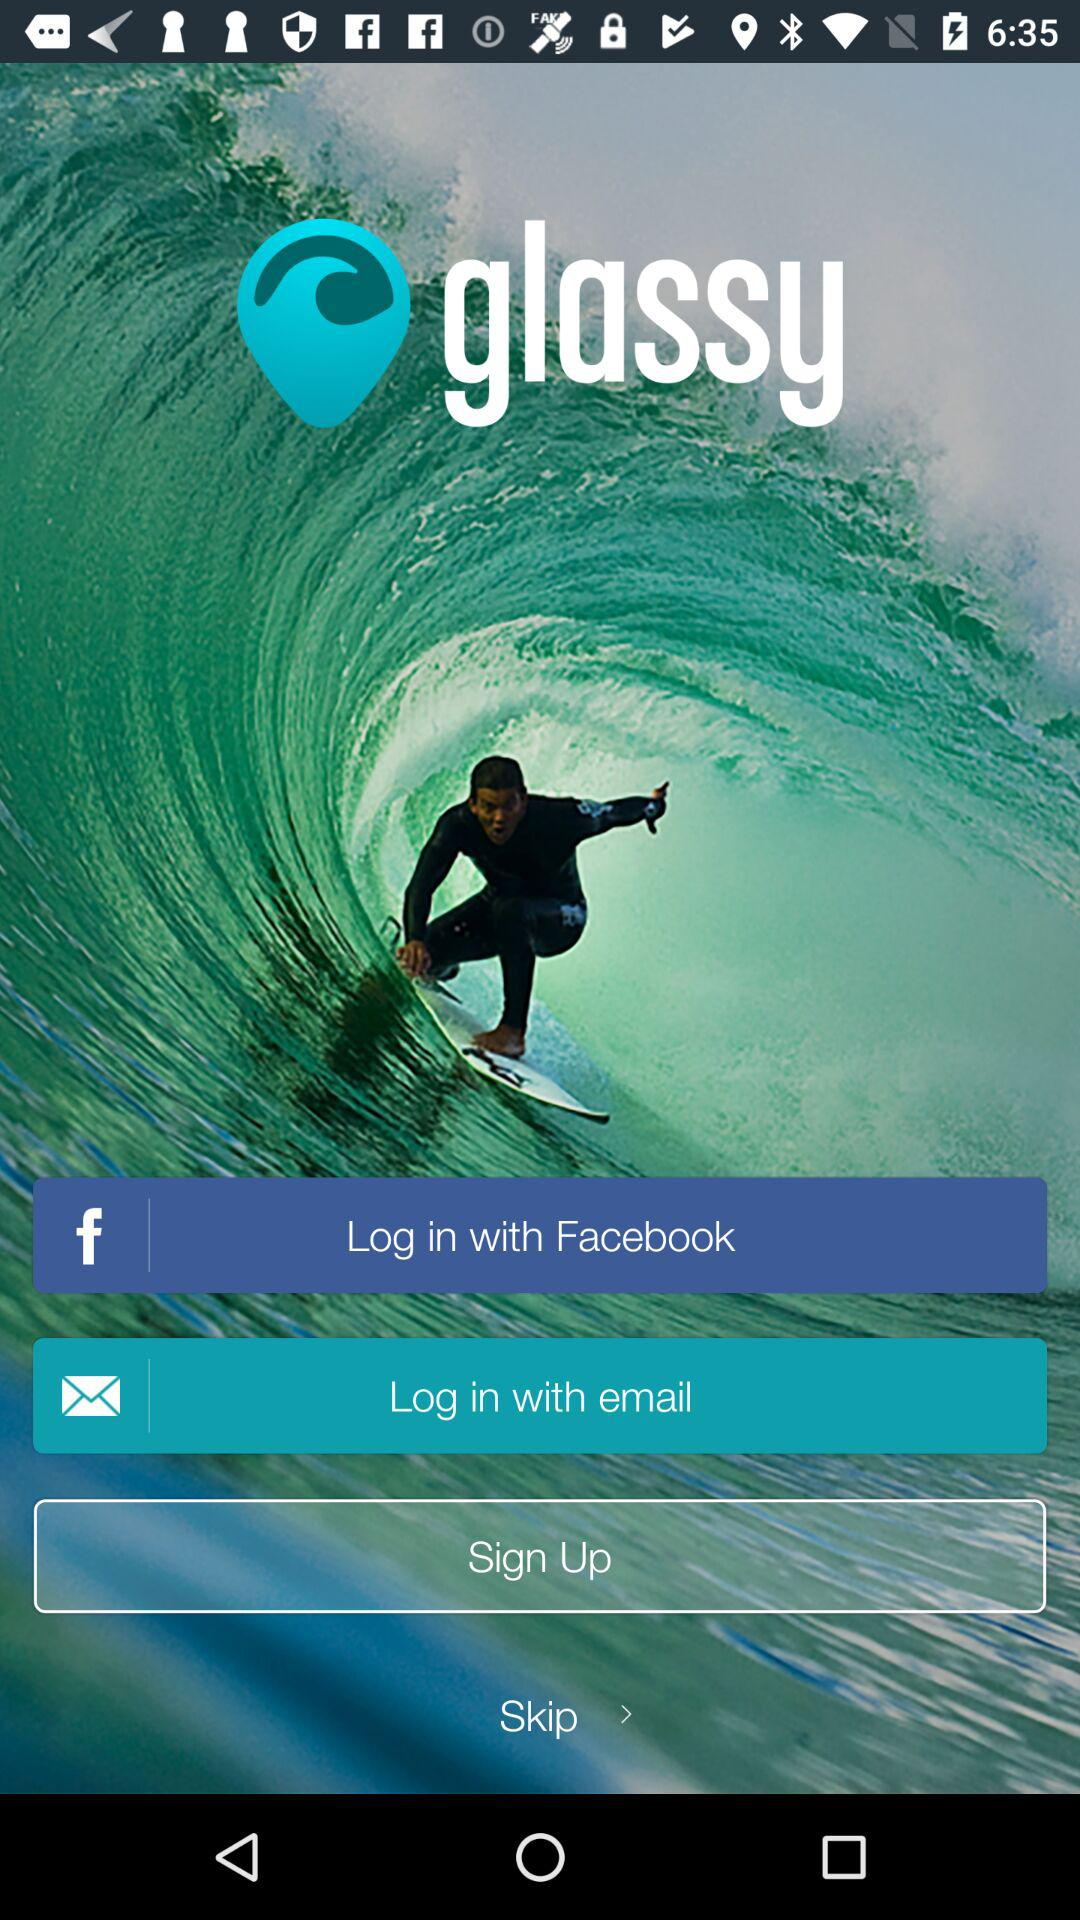Which account can be used to sign up? The accounts that can be used to sign up are "Facebook" and "email". 